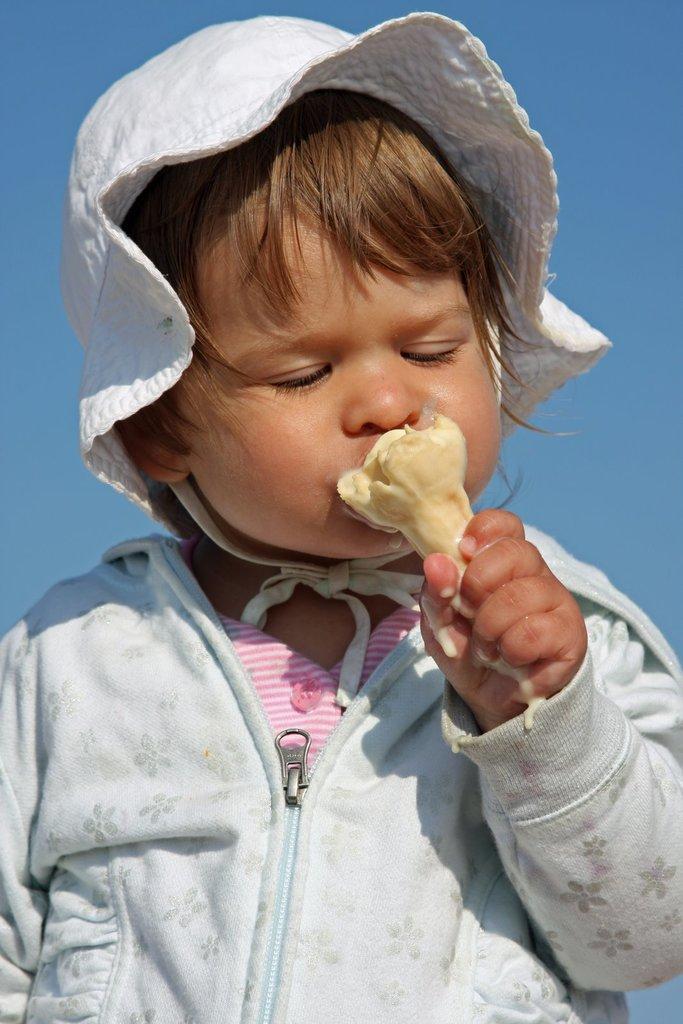Can you describe this image briefly? In this picture we can see a child and this child is holding food and in the background we can see the sky. 